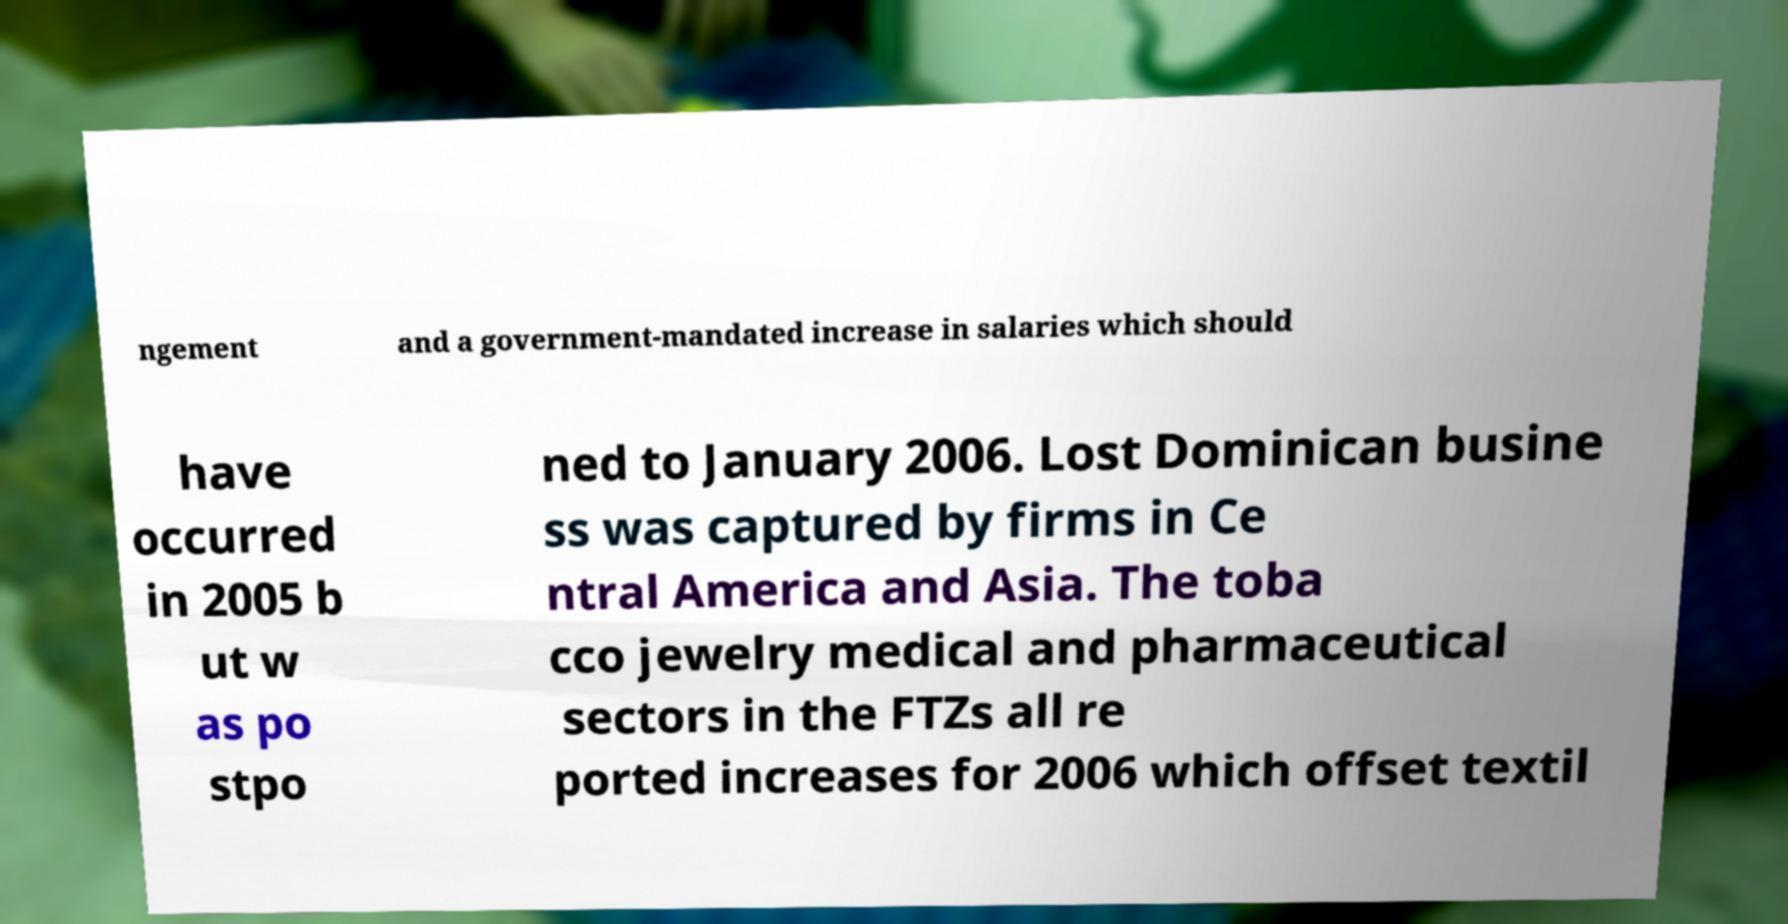What messages or text are displayed in this image? I need them in a readable, typed format. ngement and a government-mandated increase in salaries which should have occurred in 2005 b ut w as po stpo ned to January 2006. Lost Dominican busine ss was captured by firms in Ce ntral America and Asia. The toba cco jewelry medical and pharmaceutical sectors in the FTZs all re ported increases for 2006 which offset textil 